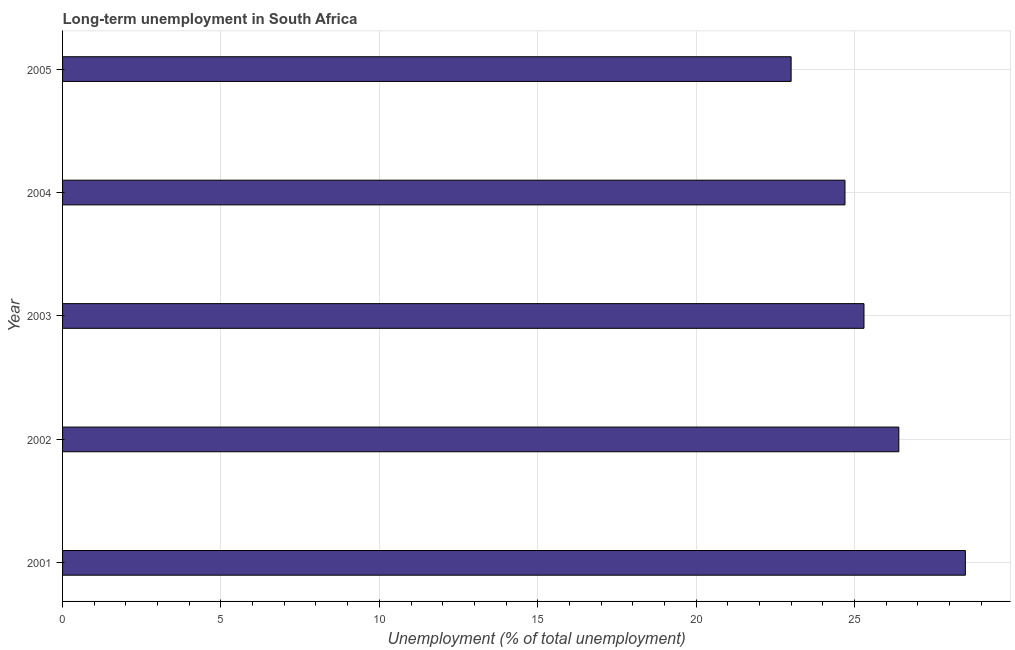What is the title of the graph?
Your response must be concise. Long-term unemployment in South Africa. What is the label or title of the X-axis?
Keep it short and to the point. Unemployment (% of total unemployment). What is the label or title of the Y-axis?
Provide a short and direct response. Year. What is the long-term unemployment in 2005?
Your response must be concise. 23. In which year was the long-term unemployment maximum?
Provide a succinct answer. 2001. What is the sum of the long-term unemployment?
Your response must be concise. 127.9. What is the average long-term unemployment per year?
Provide a succinct answer. 25.58. What is the median long-term unemployment?
Your answer should be compact. 25.3. In how many years, is the long-term unemployment greater than 9 %?
Offer a terse response. 5. What is the ratio of the long-term unemployment in 2001 to that in 2003?
Give a very brief answer. 1.13. Is the difference between the long-term unemployment in 2003 and 2004 greater than the difference between any two years?
Offer a terse response. No. What is the difference between the highest and the second highest long-term unemployment?
Your answer should be compact. 2.1. In how many years, is the long-term unemployment greater than the average long-term unemployment taken over all years?
Keep it short and to the point. 2. How many bars are there?
Make the answer very short. 5. Are all the bars in the graph horizontal?
Your answer should be compact. Yes. How many years are there in the graph?
Provide a short and direct response. 5. What is the Unemployment (% of total unemployment) in 2001?
Provide a succinct answer. 28.5. What is the Unemployment (% of total unemployment) of 2002?
Provide a succinct answer. 26.4. What is the Unemployment (% of total unemployment) of 2003?
Offer a very short reply. 25.3. What is the Unemployment (% of total unemployment) of 2004?
Your answer should be very brief. 24.7. What is the Unemployment (% of total unemployment) in 2005?
Your response must be concise. 23. What is the difference between the Unemployment (% of total unemployment) in 2001 and 2003?
Provide a short and direct response. 3.2. What is the difference between the Unemployment (% of total unemployment) in 2001 and 2004?
Ensure brevity in your answer.  3.8. What is the difference between the Unemployment (% of total unemployment) in 2004 and 2005?
Your response must be concise. 1.7. What is the ratio of the Unemployment (% of total unemployment) in 2001 to that in 2002?
Offer a terse response. 1.08. What is the ratio of the Unemployment (% of total unemployment) in 2001 to that in 2003?
Your answer should be very brief. 1.13. What is the ratio of the Unemployment (% of total unemployment) in 2001 to that in 2004?
Keep it short and to the point. 1.15. What is the ratio of the Unemployment (% of total unemployment) in 2001 to that in 2005?
Your answer should be compact. 1.24. What is the ratio of the Unemployment (% of total unemployment) in 2002 to that in 2003?
Your answer should be compact. 1.04. What is the ratio of the Unemployment (% of total unemployment) in 2002 to that in 2004?
Your answer should be very brief. 1.07. What is the ratio of the Unemployment (% of total unemployment) in 2002 to that in 2005?
Ensure brevity in your answer.  1.15. What is the ratio of the Unemployment (% of total unemployment) in 2003 to that in 2005?
Ensure brevity in your answer.  1.1. What is the ratio of the Unemployment (% of total unemployment) in 2004 to that in 2005?
Provide a succinct answer. 1.07. 